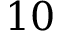<formula> <loc_0><loc_0><loc_500><loc_500>1 0</formula> 